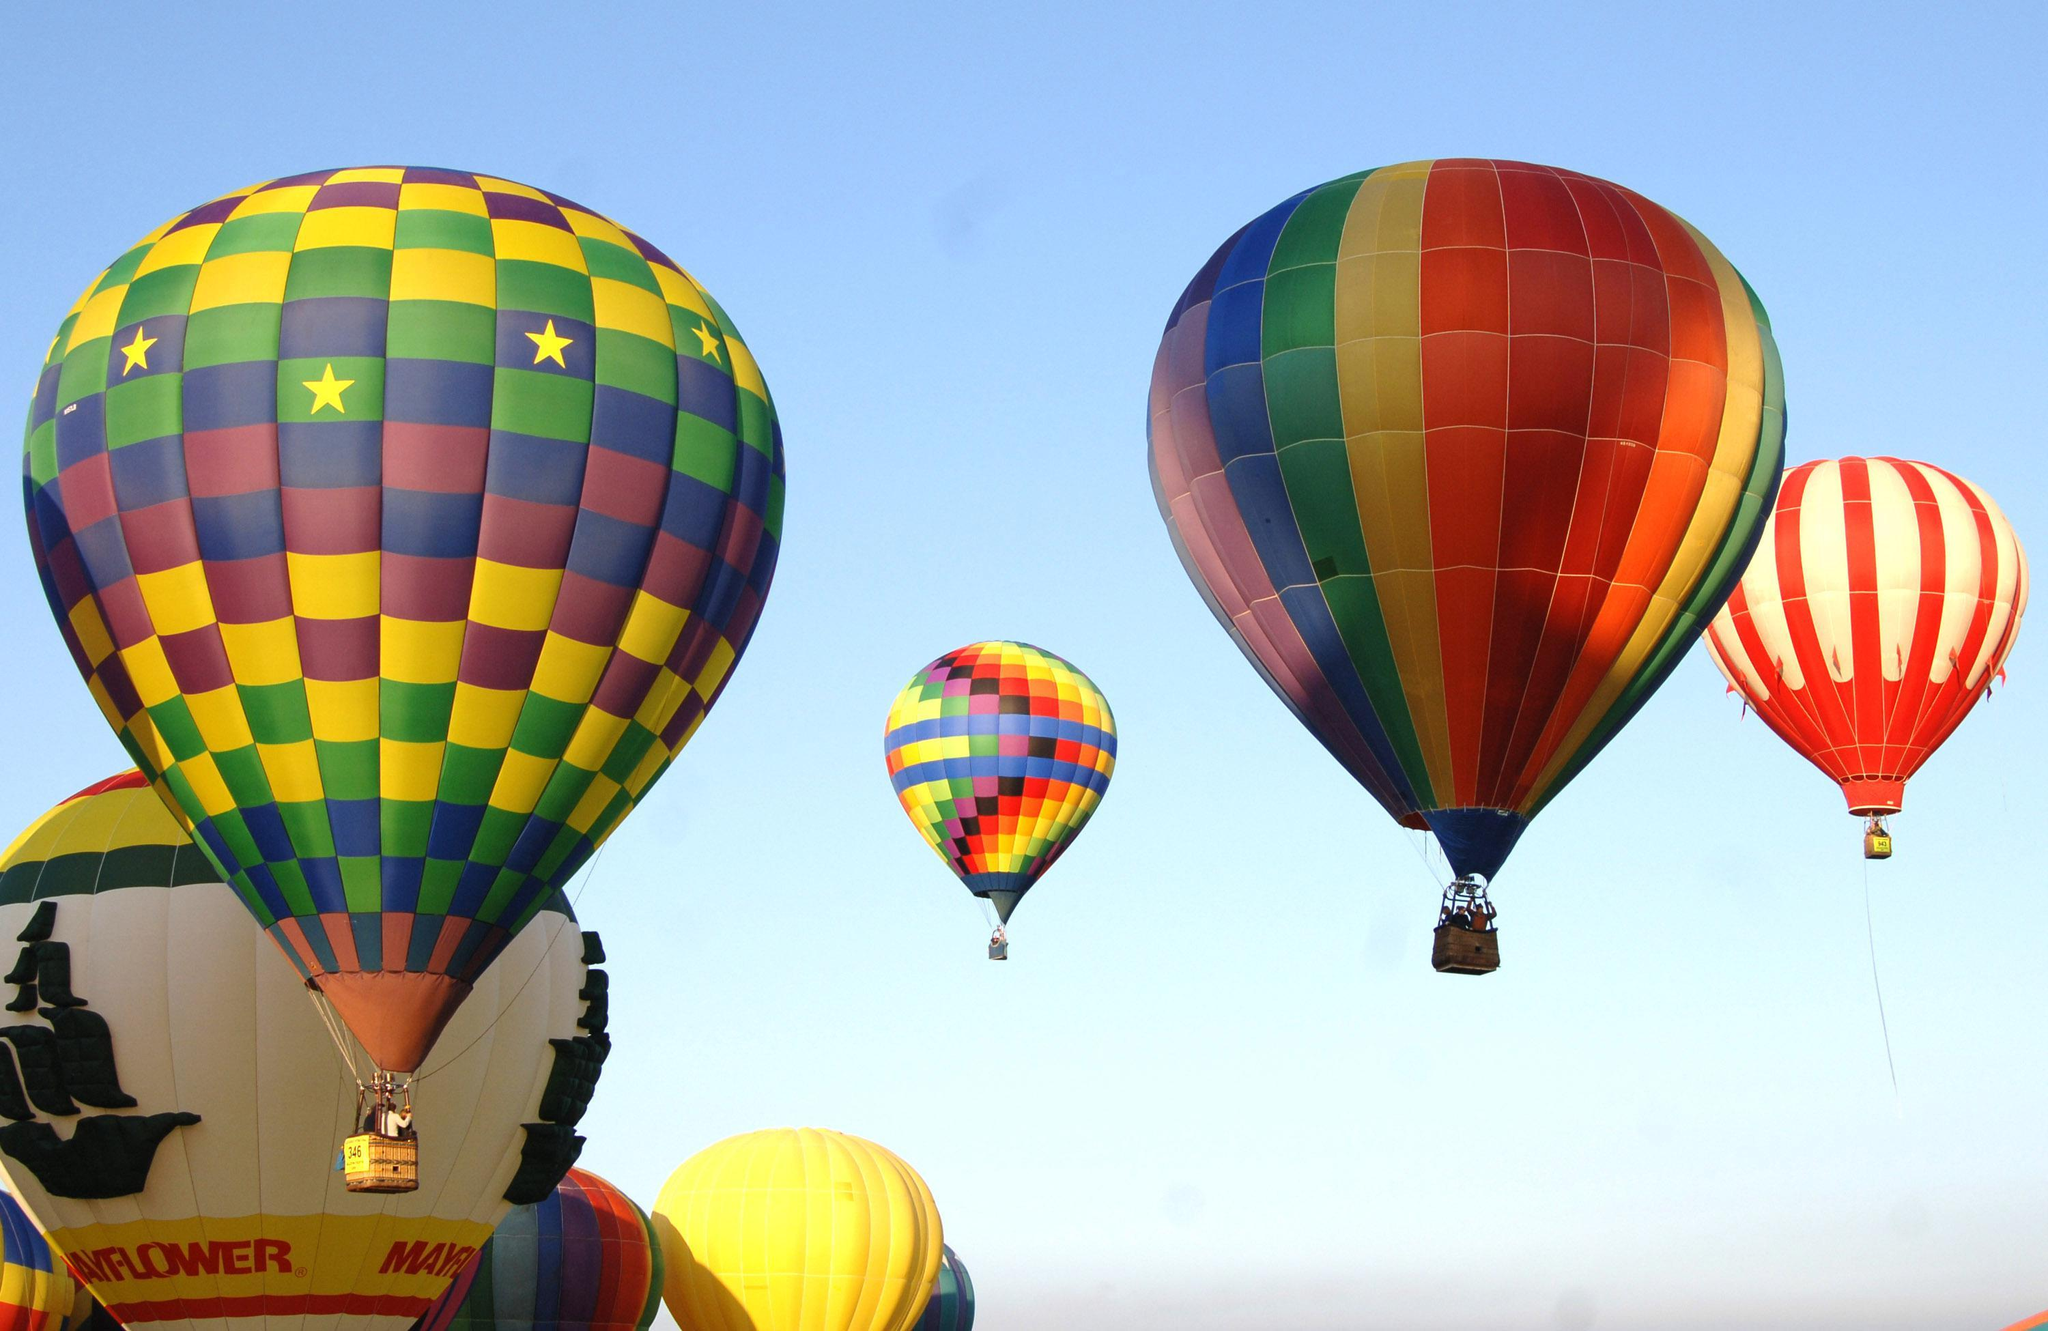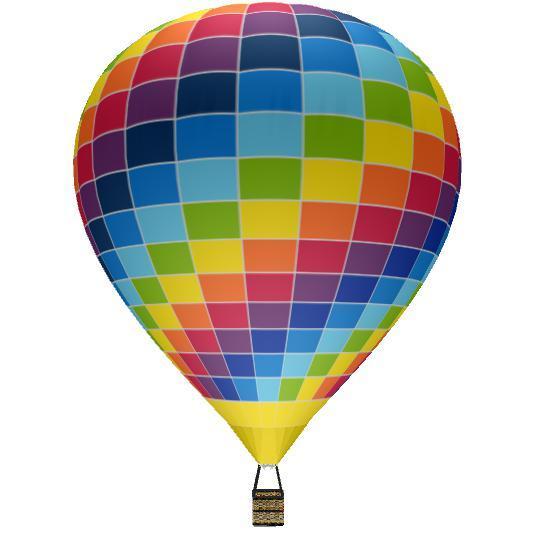The first image is the image on the left, the second image is the image on the right. Analyze the images presented: Is the assertion "There are no more than two hot air balloons." valid? Answer yes or no. No. 